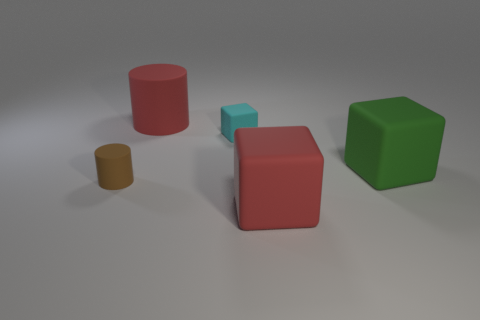How many objects are big objects in front of the big cylinder or big red rubber spheres? The image shows one large red cylinder, one large cube of the same color, and one large green cube. In front of the big red cylinder, there is one small blue cube. Therefore, there are no big objects in front of the big cylinder. Considering big red rubber spheres, none are present in this image. Given these observations, the answer to the number of 'big objects in front of the big cylinder or big red rubber spheres' is zero. 